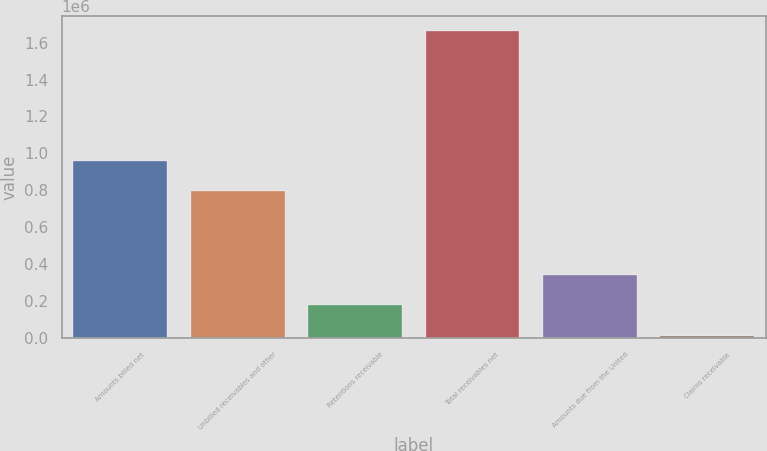<chart> <loc_0><loc_0><loc_500><loc_500><bar_chart><fcel>Amounts billed net<fcel>Unbilled receivables and other<fcel>Retentions receivable<fcel>Total receivables net<fcel>Amounts due from the United<fcel>Claims receivable<nl><fcel>958482<fcel>793918<fcel>178765<fcel>1.65984e+06<fcel>343330<fcel>14201<nl></chart> 